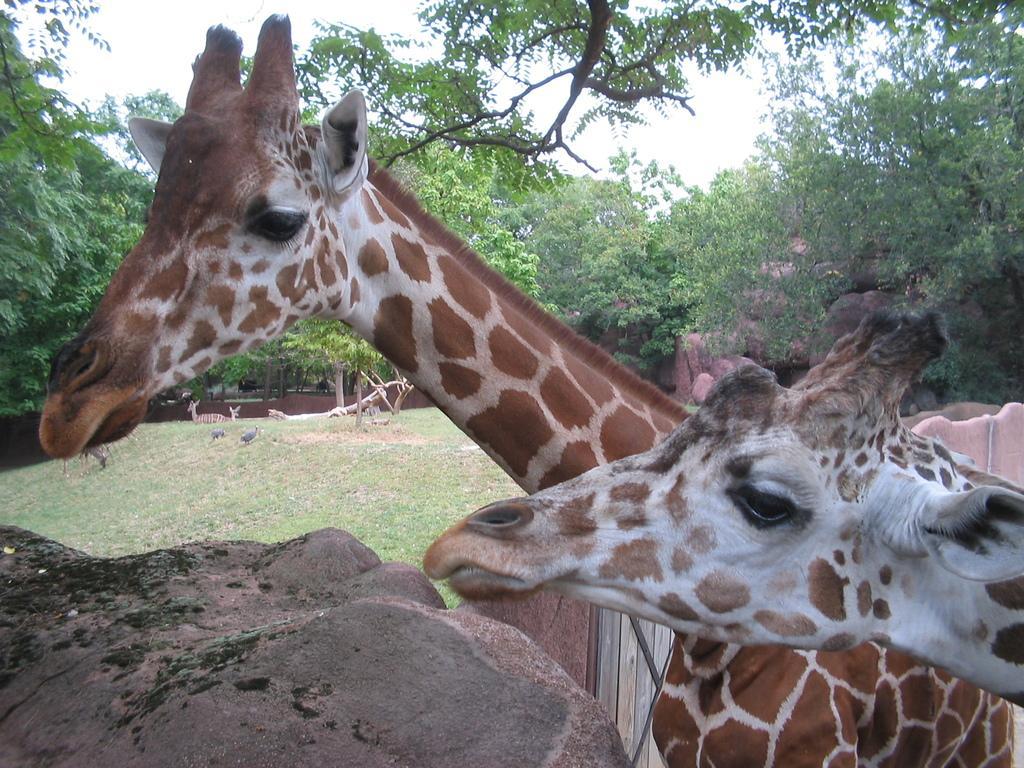Could you give a brief overview of what you see in this image? In this picture I can see some giraffes are side of the rock, behind I can see some giraffes on the grass, around there are some trees and rocks. 